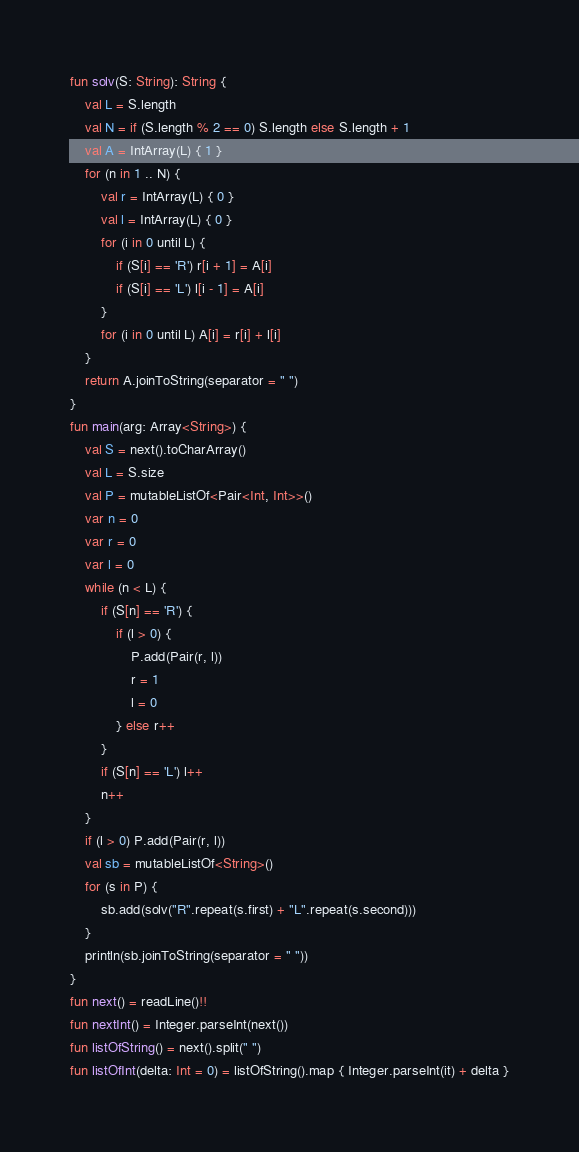Convert code to text. <code><loc_0><loc_0><loc_500><loc_500><_Kotlin_>fun solv(S: String): String {
    val L = S.length
    val N = if (S.length % 2 == 0) S.length else S.length + 1
    val A = IntArray(L) { 1 }
    for (n in 1 .. N) {
        val r = IntArray(L) { 0 }
        val l = IntArray(L) { 0 }
        for (i in 0 until L) {
            if (S[i] == 'R') r[i + 1] = A[i]
            if (S[i] == 'L') l[i - 1] = A[i]
        }
        for (i in 0 until L) A[i] = r[i] + l[i]
    }
    return A.joinToString(separator = " ")
}
fun main(arg: Array<String>) {
    val S = next().toCharArray()
    val L = S.size
    val P = mutableListOf<Pair<Int, Int>>()
    var n = 0
    var r = 0
    var l = 0
    while (n < L) {
        if (S[n] == 'R') {
            if (l > 0) {
                P.add(Pair(r, l))
                r = 1
                l = 0
            } else r++
        }
        if (S[n] == 'L') l++
        n++
    }
    if (l > 0) P.add(Pair(r, l))
    val sb = mutableListOf<String>()
    for (s in P) {
        sb.add(solv("R".repeat(s.first) + "L".repeat(s.second)))
    }
    println(sb.joinToString(separator = " "))
}
fun next() = readLine()!!
fun nextInt() = Integer.parseInt(next())
fun listOfString() = next().split(" ")
fun listOfInt(delta: Int = 0) = listOfString().map { Integer.parseInt(it) + delta }
</code> 